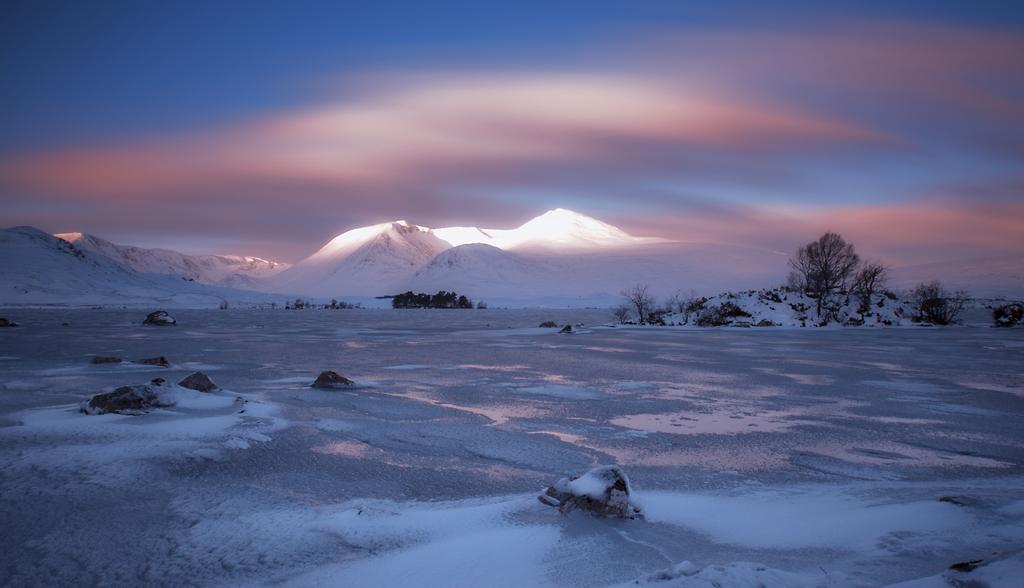Please provide a concise description of this image. In this picture we can see the mountains, trees and land covered with snow. The sky is partially gloomy. 